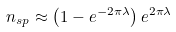Convert formula to latex. <formula><loc_0><loc_0><loc_500><loc_500>n _ { s p } \approx \left ( 1 - e ^ { - 2 \pi \lambda } \right ) e ^ { 2 \pi \lambda }</formula> 